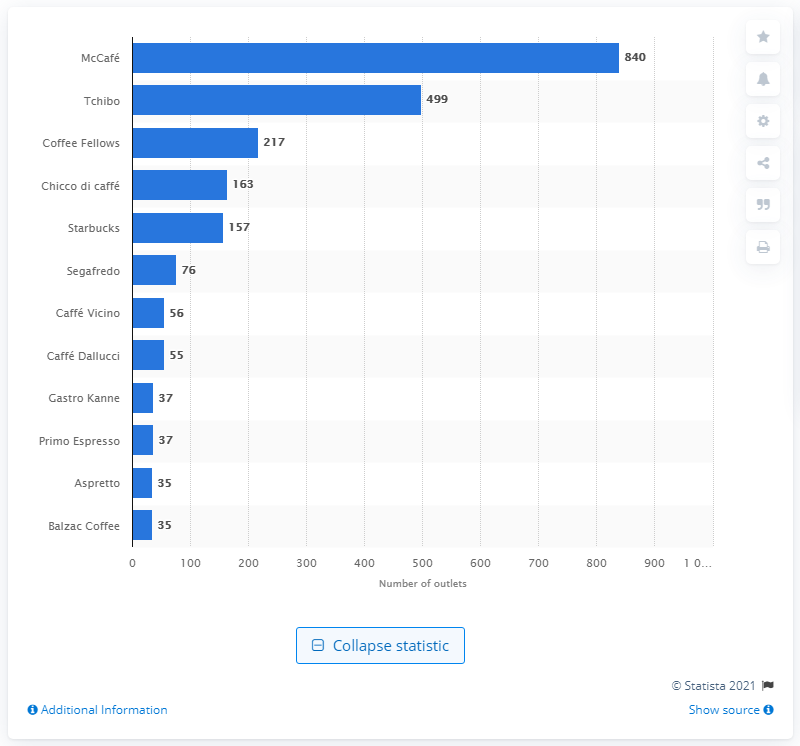Draw attention to some important aspects in this diagram. In 2018, McCaf had a total of 840 coffee shops located in Germany. 